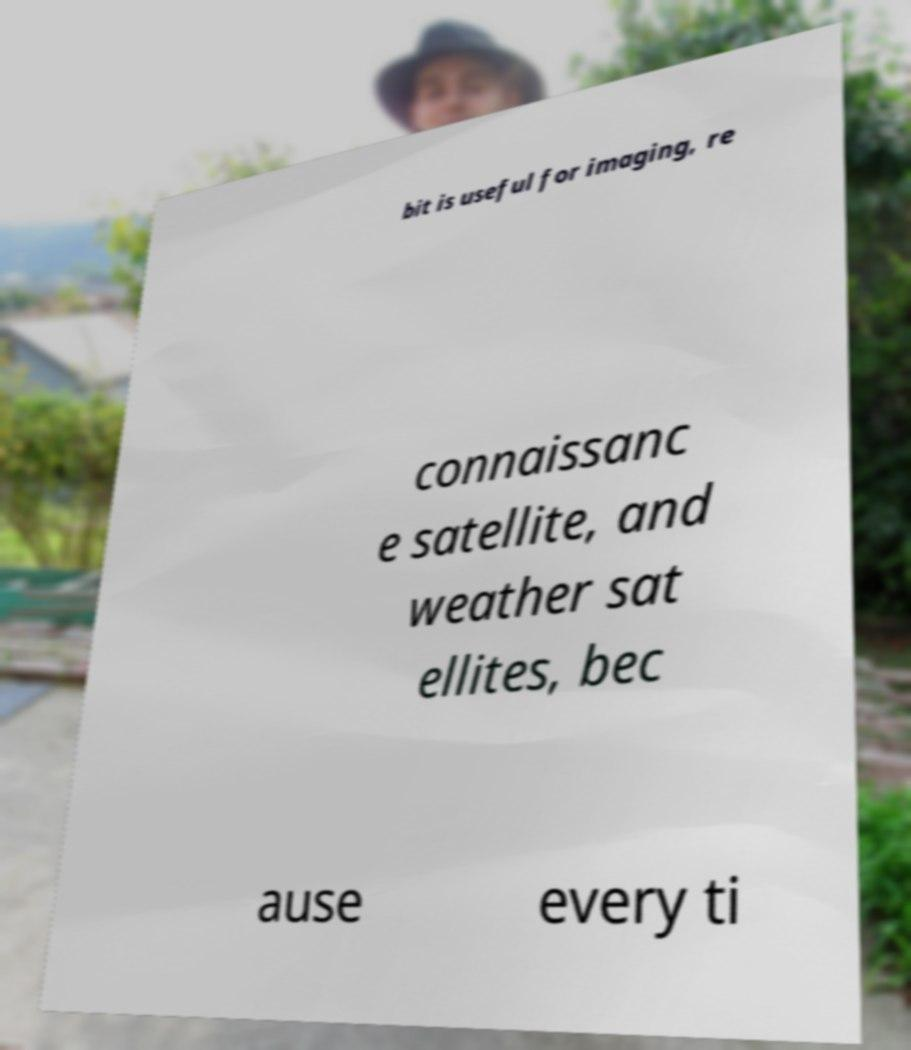What messages or text are displayed in this image? I need them in a readable, typed format. bit is useful for imaging, re connaissanc e satellite, and weather sat ellites, bec ause every ti 